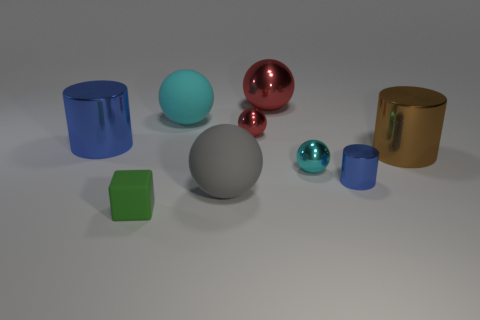How many objects are there in total, and can you categorize them based on their shapes? There are a total of eight objects in the image. There are three cylindrical objects, three spherical objects, and two cubic objects. 